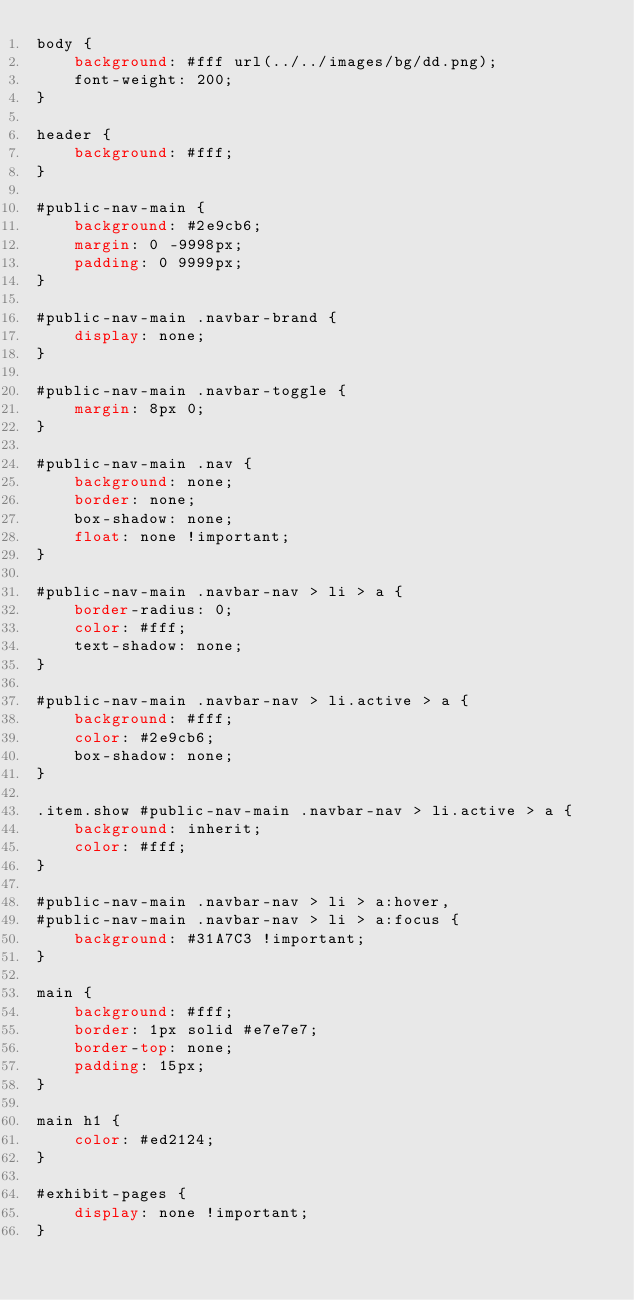<code> <loc_0><loc_0><loc_500><loc_500><_CSS_>body {
    background: #fff url(../../images/bg/dd.png);
    font-weight: 200;
}

header {
    background: #fff;
}

#public-nav-main {
    background: #2e9cb6;
    margin: 0 -9998px;
    padding: 0 9999px;
}

#public-nav-main .navbar-brand {
    display: none;
}

#public-nav-main .navbar-toggle {
    margin: 8px 0;
}

#public-nav-main .nav {
    background: none;
    border: none;
    box-shadow: none;
    float: none !important;
}

#public-nav-main .navbar-nav > li > a {
    border-radius: 0;
    color: #fff;
    text-shadow: none;
}

#public-nav-main .navbar-nav > li.active > a {
    background: #fff;
    color: #2e9cb6;
    box-shadow: none;
}

.item.show #public-nav-main .navbar-nav > li.active > a {
    background: inherit;
    color: #fff;
}

#public-nav-main .navbar-nav > li > a:hover,
#public-nav-main .navbar-nav > li > a:focus {
    background: #31A7C3 !important;
}

main {
    background: #fff;
    border: 1px solid #e7e7e7;
    border-top: none;
    padding: 15px;
}

main h1 {
    color: #ed2124;
}

#exhibit-pages {
    display: none !important;
}
</code> 